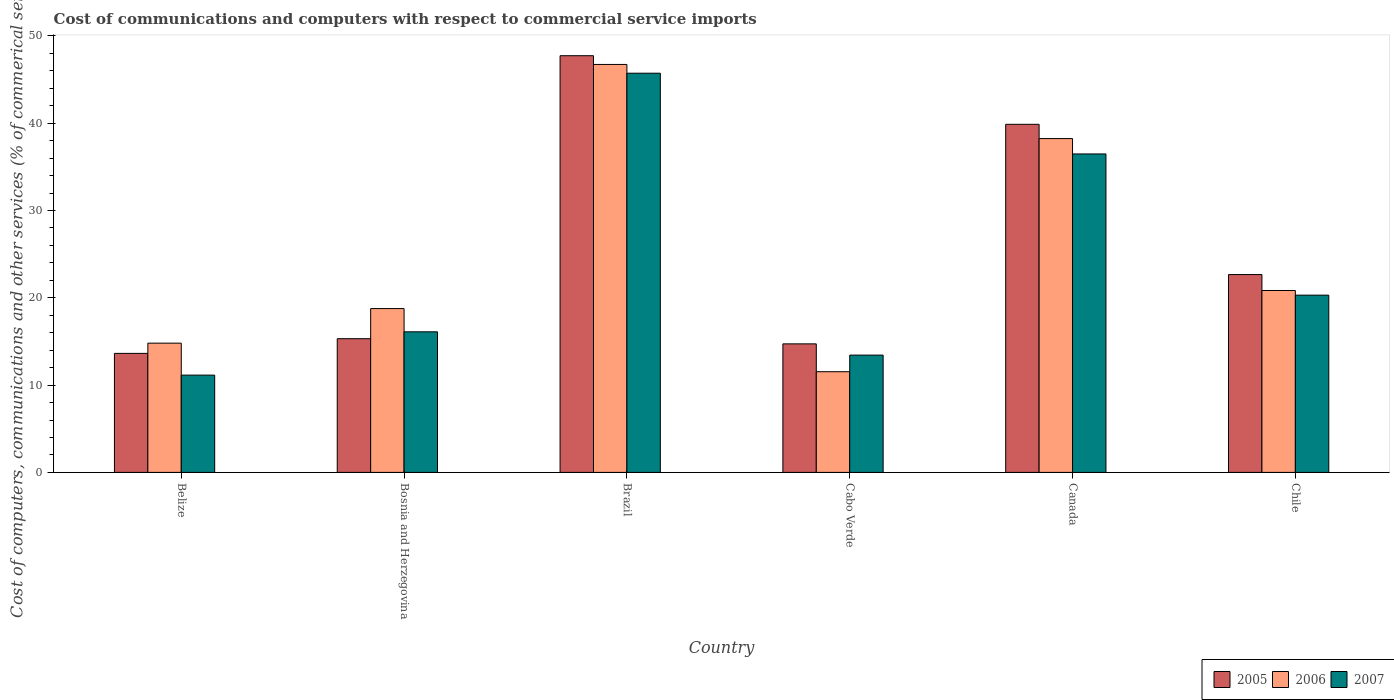How many different coloured bars are there?
Your response must be concise. 3. Are the number of bars per tick equal to the number of legend labels?
Provide a succinct answer. Yes. Are the number of bars on each tick of the X-axis equal?
Your response must be concise. Yes. How many bars are there on the 5th tick from the left?
Keep it short and to the point. 3. What is the label of the 1st group of bars from the left?
Give a very brief answer. Belize. What is the cost of communications and computers in 2005 in Chile?
Offer a very short reply. 22.66. Across all countries, what is the maximum cost of communications and computers in 2007?
Give a very brief answer. 45.72. Across all countries, what is the minimum cost of communications and computers in 2007?
Offer a very short reply. 11.14. In which country was the cost of communications and computers in 2006 maximum?
Provide a short and direct response. Brazil. In which country was the cost of communications and computers in 2005 minimum?
Make the answer very short. Belize. What is the total cost of communications and computers in 2005 in the graph?
Provide a short and direct response. 153.93. What is the difference between the cost of communications and computers in 2006 in Cabo Verde and that in Canada?
Provide a short and direct response. -26.7. What is the difference between the cost of communications and computers in 2006 in Chile and the cost of communications and computers in 2007 in Canada?
Your answer should be compact. -15.64. What is the average cost of communications and computers in 2005 per country?
Provide a succinct answer. 25.65. What is the difference between the cost of communications and computers of/in 2005 and cost of communications and computers of/in 2007 in Bosnia and Herzegovina?
Offer a terse response. -0.79. In how many countries, is the cost of communications and computers in 2005 greater than 44 %?
Ensure brevity in your answer.  1. What is the ratio of the cost of communications and computers in 2007 in Bosnia and Herzegovina to that in Brazil?
Keep it short and to the point. 0.35. What is the difference between the highest and the second highest cost of communications and computers in 2006?
Offer a terse response. 17.4. What is the difference between the highest and the lowest cost of communications and computers in 2006?
Your answer should be very brief. 35.19. Is the sum of the cost of communications and computers in 2007 in Cabo Verde and Canada greater than the maximum cost of communications and computers in 2005 across all countries?
Your answer should be very brief. Yes. Are all the bars in the graph horizontal?
Offer a very short reply. No. What is the difference between two consecutive major ticks on the Y-axis?
Your answer should be very brief. 10. Does the graph contain grids?
Offer a terse response. No. How many legend labels are there?
Make the answer very short. 3. How are the legend labels stacked?
Make the answer very short. Horizontal. What is the title of the graph?
Provide a succinct answer. Cost of communications and computers with respect to commercial service imports. What is the label or title of the Y-axis?
Give a very brief answer. Cost of computers, communications and other services (% of commerical service exports). What is the Cost of computers, communications and other services (% of commerical service exports) in 2005 in Belize?
Offer a very short reply. 13.63. What is the Cost of computers, communications and other services (% of commerical service exports) in 2006 in Belize?
Your response must be concise. 14.8. What is the Cost of computers, communications and other services (% of commerical service exports) of 2007 in Belize?
Make the answer very short. 11.14. What is the Cost of computers, communications and other services (% of commerical service exports) in 2005 in Bosnia and Herzegovina?
Your answer should be compact. 15.31. What is the Cost of computers, communications and other services (% of commerical service exports) in 2006 in Bosnia and Herzegovina?
Your response must be concise. 18.76. What is the Cost of computers, communications and other services (% of commerical service exports) in 2007 in Bosnia and Herzegovina?
Ensure brevity in your answer.  16.1. What is the Cost of computers, communications and other services (% of commerical service exports) in 2005 in Brazil?
Make the answer very short. 47.73. What is the Cost of computers, communications and other services (% of commerical service exports) in 2006 in Brazil?
Offer a very short reply. 46.73. What is the Cost of computers, communications and other services (% of commerical service exports) of 2007 in Brazil?
Offer a very short reply. 45.72. What is the Cost of computers, communications and other services (% of commerical service exports) of 2005 in Cabo Verde?
Provide a short and direct response. 14.72. What is the Cost of computers, communications and other services (% of commerical service exports) in 2006 in Cabo Verde?
Your response must be concise. 11.53. What is the Cost of computers, communications and other services (% of commerical service exports) in 2007 in Cabo Verde?
Provide a short and direct response. 13.44. What is the Cost of computers, communications and other services (% of commerical service exports) in 2005 in Canada?
Provide a succinct answer. 39.87. What is the Cost of computers, communications and other services (% of commerical service exports) in 2006 in Canada?
Your response must be concise. 38.24. What is the Cost of computers, communications and other services (% of commerical service exports) of 2007 in Canada?
Your answer should be very brief. 36.48. What is the Cost of computers, communications and other services (% of commerical service exports) of 2005 in Chile?
Your answer should be very brief. 22.66. What is the Cost of computers, communications and other services (% of commerical service exports) of 2006 in Chile?
Your answer should be very brief. 20.83. What is the Cost of computers, communications and other services (% of commerical service exports) in 2007 in Chile?
Keep it short and to the point. 20.3. Across all countries, what is the maximum Cost of computers, communications and other services (% of commerical service exports) of 2005?
Make the answer very short. 47.73. Across all countries, what is the maximum Cost of computers, communications and other services (% of commerical service exports) of 2006?
Your answer should be compact. 46.73. Across all countries, what is the maximum Cost of computers, communications and other services (% of commerical service exports) of 2007?
Give a very brief answer. 45.72. Across all countries, what is the minimum Cost of computers, communications and other services (% of commerical service exports) in 2005?
Offer a terse response. 13.63. Across all countries, what is the minimum Cost of computers, communications and other services (% of commerical service exports) of 2006?
Offer a terse response. 11.53. Across all countries, what is the minimum Cost of computers, communications and other services (% of commerical service exports) in 2007?
Provide a succinct answer. 11.14. What is the total Cost of computers, communications and other services (% of commerical service exports) in 2005 in the graph?
Offer a terse response. 153.93. What is the total Cost of computers, communications and other services (% of commerical service exports) of 2006 in the graph?
Offer a terse response. 150.9. What is the total Cost of computers, communications and other services (% of commerical service exports) in 2007 in the graph?
Offer a terse response. 143.18. What is the difference between the Cost of computers, communications and other services (% of commerical service exports) in 2005 in Belize and that in Bosnia and Herzegovina?
Make the answer very short. -1.68. What is the difference between the Cost of computers, communications and other services (% of commerical service exports) of 2006 in Belize and that in Bosnia and Herzegovina?
Provide a succinct answer. -3.96. What is the difference between the Cost of computers, communications and other services (% of commerical service exports) of 2007 in Belize and that in Bosnia and Herzegovina?
Your response must be concise. -4.96. What is the difference between the Cost of computers, communications and other services (% of commerical service exports) of 2005 in Belize and that in Brazil?
Ensure brevity in your answer.  -34.1. What is the difference between the Cost of computers, communications and other services (% of commerical service exports) of 2006 in Belize and that in Brazil?
Your answer should be compact. -31.92. What is the difference between the Cost of computers, communications and other services (% of commerical service exports) in 2007 in Belize and that in Brazil?
Your answer should be very brief. -34.58. What is the difference between the Cost of computers, communications and other services (% of commerical service exports) of 2005 in Belize and that in Cabo Verde?
Your response must be concise. -1.09. What is the difference between the Cost of computers, communications and other services (% of commerical service exports) in 2006 in Belize and that in Cabo Verde?
Offer a terse response. 3.27. What is the difference between the Cost of computers, communications and other services (% of commerical service exports) of 2007 in Belize and that in Cabo Verde?
Your response must be concise. -2.29. What is the difference between the Cost of computers, communications and other services (% of commerical service exports) of 2005 in Belize and that in Canada?
Make the answer very short. -26.24. What is the difference between the Cost of computers, communications and other services (% of commerical service exports) of 2006 in Belize and that in Canada?
Make the answer very short. -23.43. What is the difference between the Cost of computers, communications and other services (% of commerical service exports) in 2007 in Belize and that in Canada?
Provide a short and direct response. -25.33. What is the difference between the Cost of computers, communications and other services (% of commerical service exports) in 2005 in Belize and that in Chile?
Offer a very short reply. -9.03. What is the difference between the Cost of computers, communications and other services (% of commerical service exports) of 2006 in Belize and that in Chile?
Provide a succinct answer. -6.03. What is the difference between the Cost of computers, communications and other services (% of commerical service exports) of 2007 in Belize and that in Chile?
Keep it short and to the point. -9.16. What is the difference between the Cost of computers, communications and other services (% of commerical service exports) in 2005 in Bosnia and Herzegovina and that in Brazil?
Provide a succinct answer. -32.41. What is the difference between the Cost of computers, communications and other services (% of commerical service exports) in 2006 in Bosnia and Herzegovina and that in Brazil?
Your answer should be very brief. -27.96. What is the difference between the Cost of computers, communications and other services (% of commerical service exports) of 2007 in Bosnia and Herzegovina and that in Brazil?
Your answer should be compact. -29.62. What is the difference between the Cost of computers, communications and other services (% of commerical service exports) of 2005 in Bosnia and Herzegovina and that in Cabo Verde?
Offer a very short reply. 0.59. What is the difference between the Cost of computers, communications and other services (% of commerical service exports) in 2006 in Bosnia and Herzegovina and that in Cabo Verde?
Provide a short and direct response. 7.23. What is the difference between the Cost of computers, communications and other services (% of commerical service exports) of 2007 in Bosnia and Herzegovina and that in Cabo Verde?
Offer a very short reply. 2.67. What is the difference between the Cost of computers, communications and other services (% of commerical service exports) of 2005 in Bosnia and Herzegovina and that in Canada?
Offer a very short reply. -24.55. What is the difference between the Cost of computers, communications and other services (% of commerical service exports) in 2006 in Bosnia and Herzegovina and that in Canada?
Offer a terse response. -19.47. What is the difference between the Cost of computers, communications and other services (% of commerical service exports) of 2007 in Bosnia and Herzegovina and that in Canada?
Offer a terse response. -20.38. What is the difference between the Cost of computers, communications and other services (% of commerical service exports) of 2005 in Bosnia and Herzegovina and that in Chile?
Provide a short and direct response. -7.35. What is the difference between the Cost of computers, communications and other services (% of commerical service exports) in 2006 in Bosnia and Herzegovina and that in Chile?
Ensure brevity in your answer.  -2.07. What is the difference between the Cost of computers, communications and other services (% of commerical service exports) of 2007 in Bosnia and Herzegovina and that in Chile?
Ensure brevity in your answer.  -4.2. What is the difference between the Cost of computers, communications and other services (% of commerical service exports) in 2005 in Brazil and that in Cabo Verde?
Provide a short and direct response. 33.01. What is the difference between the Cost of computers, communications and other services (% of commerical service exports) of 2006 in Brazil and that in Cabo Verde?
Your answer should be very brief. 35.19. What is the difference between the Cost of computers, communications and other services (% of commerical service exports) in 2007 in Brazil and that in Cabo Verde?
Offer a very short reply. 32.29. What is the difference between the Cost of computers, communications and other services (% of commerical service exports) of 2005 in Brazil and that in Canada?
Ensure brevity in your answer.  7.86. What is the difference between the Cost of computers, communications and other services (% of commerical service exports) of 2006 in Brazil and that in Canada?
Your answer should be compact. 8.49. What is the difference between the Cost of computers, communications and other services (% of commerical service exports) in 2007 in Brazil and that in Canada?
Make the answer very short. 9.25. What is the difference between the Cost of computers, communications and other services (% of commerical service exports) of 2005 in Brazil and that in Chile?
Offer a terse response. 25.07. What is the difference between the Cost of computers, communications and other services (% of commerical service exports) in 2006 in Brazil and that in Chile?
Ensure brevity in your answer.  25.89. What is the difference between the Cost of computers, communications and other services (% of commerical service exports) of 2007 in Brazil and that in Chile?
Make the answer very short. 25.42. What is the difference between the Cost of computers, communications and other services (% of commerical service exports) in 2005 in Cabo Verde and that in Canada?
Provide a succinct answer. -25.15. What is the difference between the Cost of computers, communications and other services (% of commerical service exports) in 2006 in Cabo Verde and that in Canada?
Offer a very short reply. -26.7. What is the difference between the Cost of computers, communications and other services (% of commerical service exports) in 2007 in Cabo Verde and that in Canada?
Keep it short and to the point. -23.04. What is the difference between the Cost of computers, communications and other services (% of commerical service exports) in 2005 in Cabo Verde and that in Chile?
Offer a terse response. -7.94. What is the difference between the Cost of computers, communications and other services (% of commerical service exports) of 2007 in Cabo Verde and that in Chile?
Provide a short and direct response. -6.87. What is the difference between the Cost of computers, communications and other services (% of commerical service exports) of 2005 in Canada and that in Chile?
Offer a terse response. 17.21. What is the difference between the Cost of computers, communications and other services (% of commerical service exports) in 2006 in Canada and that in Chile?
Make the answer very short. 17.4. What is the difference between the Cost of computers, communications and other services (% of commerical service exports) of 2007 in Canada and that in Chile?
Offer a very short reply. 16.17. What is the difference between the Cost of computers, communications and other services (% of commerical service exports) in 2005 in Belize and the Cost of computers, communications and other services (% of commerical service exports) in 2006 in Bosnia and Herzegovina?
Your response must be concise. -5.13. What is the difference between the Cost of computers, communications and other services (% of commerical service exports) of 2005 in Belize and the Cost of computers, communications and other services (% of commerical service exports) of 2007 in Bosnia and Herzegovina?
Offer a terse response. -2.47. What is the difference between the Cost of computers, communications and other services (% of commerical service exports) in 2006 in Belize and the Cost of computers, communications and other services (% of commerical service exports) in 2007 in Bosnia and Herzegovina?
Your answer should be compact. -1.3. What is the difference between the Cost of computers, communications and other services (% of commerical service exports) in 2005 in Belize and the Cost of computers, communications and other services (% of commerical service exports) in 2006 in Brazil?
Give a very brief answer. -33.1. What is the difference between the Cost of computers, communications and other services (% of commerical service exports) of 2005 in Belize and the Cost of computers, communications and other services (% of commerical service exports) of 2007 in Brazil?
Ensure brevity in your answer.  -32.09. What is the difference between the Cost of computers, communications and other services (% of commerical service exports) in 2006 in Belize and the Cost of computers, communications and other services (% of commerical service exports) in 2007 in Brazil?
Give a very brief answer. -30.92. What is the difference between the Cost of computers, communications and other services (% of commerical service exports) of 2005 in Belize and the Cost of computers, communications and other services (% of commerical service exports) of 2006 in Cabo Verde?
Keep it short and to the point. 2.1. What is the difference between the Cost of computers, communications and other services (% of commerical service exports) in 2005 in Belize and the Cost of computers, communications and other services (% of commerical service exports) in 2007 in Cabo Verde?
Keep it short and to the point. 0.2. What is the difference between the Cost of computers, communications and other services (% of commerical service exports) of 2006 in Belize and the Cost of computers, communications and other services (% of commerical service exports) of 2007 in Cabo Verde?
Offer a very short reply. 1.37. What is the difference between the Cost of computers, communications and other services (% of commerical service exports) of 2005 in Belize and the Cost of computers, communications and other services (% of commerical service exports) of 2006 in Canada?
Your answer should be very brief. -24.6. What is the difference between the Cost of computers, communications and other services (% of commerical service exports) of 2005 in Belize and the Cost of computers, communications and other services (% of commerical service exports) of 2007 in Canada?
Keep it short and to the point. -22.84. What is the difference between the Cost of computers, communications and other services (% of commerical service exports) in 2006 in Belize and the Cost of computers, communications and other services (% of commerical service exports) in 2007 in Canada?
Your answer should be compact. -21.67. What is the difference between the Cost of computers, communications and other services (% of commerical service exports) in 2005 in Belize and the Cost of computers, communications and other services (% of commerical service exports) in 2006 in Chile?
Offer a terse response. -7.2. What is the difference between the Cost of computers, communications and other services (% of commerical service exports) of 2005 in Belize and the Cost of computers, communications and other services (% of commerical service exports) of 2007 in Chile?
Provide a succinct answer. -6.67. What is the difference between the Cost of computers, communications and other services (% of commerical service exports) of 2006 in Belize and the Cost of computers, communications and other services (% of commerical service exports) of 2007 in Chile?
Make the answer very short. -5.5. What is the difference between the Cost of computers, communications and other services (% of commerical service exports) in 2005 in Bosnia and Herzegovina and the Cost of computers, communications and other services (% of commerical service exports) in 2006 in Brazil?
Offer a very short reply. -31.41. What is the difference between the Cost of computers, communications and other services (% of commerical service exports) of 2005 in Bosnia and Herzegovina and the Cost of computers, communications and other services (% of commerical service exports) of 2007 in Brazil?
Provide a succinct answer. -30.41. What is the difference between the Cost of computers, communications and other services (% of commerical service exports) in 2006 in Bosnia and Herzegovina and the Cost of computers, communications and other services (% of commerical service exports) in 2007 in Brazil?
Ensure brevity in your answer.  -26.96. What is the difference between the Cost of computers, communications and other services (% of commerical service exports) of 2005 in Bosnia and Herzegovina and the Cost of computers, communications and other services (% of commerical service exports) of 2006 in Cabo Verde?
Provide a short and direct response. 3.78. What is the difference between the Cost of computers, communications and other services (% of commerical service exports) in 2005 in Bosnia and Herzegovina and the Cost of computers, communications and other services (% of commerical service exports) in 2007 in Cabo Verde?
Offer a terse response. 1.88. What is the difference between the Cost of computers, communications and other services (% of commerical service exports) in 2006 in Bosnia and Herzegovina and the Cost of computers, communications and other services (% of commerical service exports) in 2007 in Cabo Verde?
Provide a short and direct response. 5.33. What is the difference between the Cost of computers, communications and other services (% of commerical service exports) in 2005 in Bosnia and Herzegovina and the Cost of computers, communications and other services (% of commerical service exports) in 2006 in Canada?
Your answer should be compact. -22.92. What is the difference between the Cost of computers, communications and other services (% of commerical service exports) of 2005 in Bosnia and Herzegovina and the Cost of computers, communications and other services (% of commerical service exports) of 2007 in Canada?
Your response must be concise. -21.16. What is the difference between the Cost of computers, communications and other services (% of commerical service exports) of 2006 in Bosnia and Herzegovina and the Cost of computers, communications and other services (% of commerical service exports) of 2007 in Canada?
Your answer should be very brief. -17.71. What is the difference between the Cost of computers, communications and other services (% of commerical service exports) in 2005 in Bosnia and Herzegovina and the Cost of computers, communications and other services (% of commerical service exports) in 2006 in Chile?
Your answer should be very brief. -5.52. What is the difference between the Cost of computers, communications and other services (% of commerical service exports) in 2005 in Bosnia and Herzegovina and the Cost of computers, communications and other services (% of commerical service exports) in 2007 in Chile?
Your answer should be very brief. -4.99. What is the difference between the Cost of computers, communications and other services (% of commerical service exports) in 2006 in Bosnia and Herzegovina and the Cost of computers, communications and other services (% of commerical service exports) in 2007 in Chile?
Provide a short and direct response. -1.54. What is the difference between the Cost of computers, communications and other services (% of commerical service exports) in 2005 in Brazil and the Cost of computers, communications and other services (% of commerical service exports) in 2006 in Cabo Verde?
Keep it short and to the point. 36.2. What is the difference between the Cost of computers, communications and other services (% of commerical service exports) of 2005 in Brazil and the Cost of computers, communications and other services (% of commerical service exports) of 2007 in Cabo Verde?
Your response must be concise. 34.29. What is the difference between the Cost of computers, communications and other services (% of commerical service exports) in 2006 in Brazil and the Cost of computers, communications and other services (% of commerical service exports) in 2007 in Cabo Verde?
Ensure brevity in your answer.  33.29. What is the difference between the Cost of computers, communications and other services (% of commerical service exports) of 2005 in Brazil and the Cost of computers, communications and other services (% of commerical service exports) of 2006 in Canada?
Provide a short and direct response. 9.49. What is the difference between the Cost of computers, communications and other services (% of commerical service exports) in 2005 in Brazil and the Cost of computers, communications and other services (% of commerical service exports) in 2007 in Canada?
Make the answer very short. 11.25. What is the difference between the Cost of computers, communications and other services (% of commerical service exports) in 2006 in Brazil and the Cost of computers, communications and other services (% of commerical service exports) in 2007 in Canada?
Make the answer very short. 10.25. What is the difference between the Cost of computers, communications and other services (% of commerical service exports) of 2005 in Brazil and the Cost of computers, communications and other services (% of commerical service exports) of 2006 in Chile?
Ensure brevity in your answer.  26.89. What is the difference between the Cost of computers, communications and other services (% of commerical service exports) of 2005 in Brazil and the Cost of computers, communications and other services (% of commerical service exports) of 2007 in Chile?
Give a very brief answer. 27.43. What is the difference between the Cost of computers, communications and other services (% of commerical service exports) of 2006 in Brazil and the Cost of computers, communications and other services (% of commerical service exports) of 2007 in Chile?
Offer a very short reply. 26.42. What is the difference between the Cost of computers, communications and other services (% of commerical service exports) in 2005 in Cabo Verde and the Cost of computers, communications and other services (% of commerical service exports) in 2006 in Canada?
Your answer should be compact. -23.51. What is the difference between the Cost of computers, communications and other services (% of commerical service exports) of 2005 in Cabo Verde and the Cost of computers, communications and other services (% of commerical service exports) of 2007 in Canada?
Offer a very short reply. -21.75. What is the difference between the Cost of computers, communications and other services (% of commerical service exports) of 2006 in Cabo Verde and the Cost of computers, communications and other services (% of commerical service exports) of 2007 in Canada?
Give a very brief answer. -24.94. What is the difference between the Cost of computers, communications and other services (% of commerical service exports) of 2005 in Cabo Verde and the Cost of computers, communications and other services (% of commerical service exports) of 2006 in Chile?
Keep it short and to the point. -6.11. What is the difference between the Cost of computers, communications and other services (% of commerical service exports) in 2005 in Cabo Verde and the Cost of computers, communications and other services (% of commerical service exports) in 2007 in Chile?
Your answer should be compact. -5.58. What is the difference between the Cost of computers, communications and other services (% of commerical service exports) of 2006 in Cabo Verde and the Cost of computers, communications and other services (% of commerical service exports) of 2007 in Chile?
Ensure brevity in your answer.  -8.77. What is the difference between the Cost of computers, communications and other services (% of commerical service exports) of 2005 in Canada and the Cost of computers, communications and other services (% of commerical service exports) of 2006 in Chile?
Provide a short and direct response. 19.04. What is the difference between the Cost of computers, communications and other services (% of commerical service exports) in 2005 in Canada and the Cost of computers, communications and other services (% of commerical service exports) in 2007 in Chile?
Your answer should be very brief. 19.57. What is the difference between the Cost of computers, communications and other services (% of commerical service exports) in 2006 in Canada and the Cost of computers, communications and other services (% of commerical service exports) in 2007 in Chile?
Provide a short and direct response. 17.93. What is the average Cost of computers, communications and other services (% of commerical service exports) of 2005 per country?
Your answer should be compact. 25.65. What is the average Cost of computers, communications and other services (% of commerical service exports) of 2006 per country?
Provide a short and direct response. 25.15. What is the average Cost of computers, communications and other services (% of commerical service exports) in 2007 per country?
Keep it short and to the point. 23.86. What is the difference between the Cost of computers, communications and other services (% of commerical service exports) of 2005 and Cost of computers, communications and other services (% of commerical service exports) of 2006 in Belize?
Make the answer very short. -1.17. What is the difference between the Cost of computers, communications and other services (% of commerical service exports) of 2005 and Cost of computers, communications and other services (% of commerical service exports) of 2007 in Belize?
Your answer should be compact. 2.49. What is the difference between the Cost of computers, communications and other services (% of commerical service exports) in 2006 and Cost of computers, communications and other services (% of commerical service exports) in 2007 in Belize?
Offer a terse response. 3.66. What is the difference between the Cost of computers, communications and other services (% of commerical service exports) of 2005 and Cost of computers, communications and other services (% of commerical service exports) of 2006 in Bosnia and Herzegovina?
Your answer should be very brief. -3.45. What is the difference between the Cost of computers, communications and other services (% of commerical service exports) of 2005 and Cost of computers, communications and other services (% of commerical service exports) of 2007 in Bosnia and Herzegovina?
Provide a succinct answer. -0.79. What is the difference between the Cost of computers, communications and other services (% of commerical service exports) in 2006 and Cost of computers, communications and other services (% of commerical service exports) in 2007 in Bosnia and Herzegovina?
Your answer should be very brief. 2.66. What is the difference between the Cost of computers, communications and other services (% of commerical service exports) in 2005 and Cost of computers, communications and other services (% of commerical service exports) in 2007 in Brazil?
Offer a terse response. 2. What is the difference between the Cost of computers, communications and other services (% of commerical service exports) of 2006 and Cost of computers, communications and other services (% of commerical service exports) of 2007 in Brazil?
Give a very brief answer. 1. What is the difference between the Cost of computers, communications and other services (% of commerical service exports) in 2005 and Cost of computers, communications and other services (% of commerical service exports) in 2006 in Cabo Verde?
Provide a short and direct response. 3.19. What is the difference between the Cost of computers, communications and other services (% of commerical service exports) of 2005 and Cost of computers, communications and other services (% of commerical service exports) of 2007 in Cabo Verde?
Offer a terse response. 1.29. What is the difference between the Cost of computers, communications and other services (% of commerical service exports) in 2006 and Cost of computers, communications and other services (% of commerical service exports) in 2007 in Cabo Verde?
Your answer should be compact. -1.9. What is the difference between the Cost of computers, communications and other services (% of commerical service exports) in 2005 and Cost of computers, communications and other services (% of commerical service exports) in 2006 in Canada?
Offer a terse response. 1.63. What is the difference between the Cost of computers, communications and other services (% of commerical service exports) of 2005 and Cost of computers, communications and other services (% of commerical service exports) of 2007 in Canada?
Provide a succinct answer. 3.39. What is the difference between the Cost of computers, communications and other services (% of commerical service exports) of 2006 and Cost of computers, communications and other services (% of commerical service exports) of 2007 in Canada?
Your answer should be compact. 1.76. What is the difference between the Cost of computers, communications and other services (% of commerical service exports) in 2005 and Cost of computers, communications and other services (% of commerical service exports) in 2006 in Chile?
Ensure brevity in your answer.  1.83. What is the difference between the Cost of computers, communications and other services (% of commerical service exports) in 2005 and Cost of computers, communications and other services (% of commerical service exports) in 2007 in Chile?
Keep it short and to the point. 2.36. What is the difference between the Cost of computers, communications and other services (% of commerical service exports) in 2006 and Cost of computers, communications and other services (% of commerical service exports) in 2007 in Chile?
Offer a very short reply. 0.53. What is the ratio of the Cost of computers, communications and other services (% of commerical service exports) in 2005 in Belize to that in Bosnia and Herzegovina?
Provide a succinct answer. 0.89. What is the ratio of the Cost of computers, communications and other services (% of commerical service exports) in 2006 in Belize to that in Bosnia and Herzegovina?
Provide a short and direct response. 0.79. What is the ratio of the Cost of computers, communications and other services (% of commerical service exports) of 2007 in Belize to that in Bosnia and Herzegovina?
Your answer should be very brief. 0.69. What is the ratio of the Cost of computers, communications and other services (% of commerical service exports) of 2005 in Belize to that in Brazil?
Offer a very short reply. 0.29. What is the ratio of the Cost of computers, communications and other services (% of commerical service exports) of 2006 in Belize to that in Brazil?
Provide a short and direct response. 0.32. What is the ratio of the Cost of computers, communications and other services (% of commerical service exports) in 2007 in Belize to that in Brazil?
Your answer should be very brief. 0.24. What is the ratio of the Cost of computers, communications and other services (% of commerical service exports) of 2005 in Belize to that in Cabo Verde?
Make the answer very short. 0.93. What is the ratio of the Cost of computers, communications and other services (% of commerical service exports) of 2006 in Belize to that in Cabo Verde?
Provide a succinct answer. 1.28. What is the ratio of the Cost of computers, communications and other services (% of commerical service exports) in 2007 in Belize to that in Cabo Verde?
Provide a short and direct response. 0.83. What is the ratio of the Cost of computers, communications and other services (% of commerical service exports) of 2005 in Belize to that in Canada?
Ensure brevity in your answer.  0.34. What is the ratio of the Cost of computers, communications and other services (% of commerical service exports) in 2006 in Belize to that in Canada?
Your response must be concise. 0.39. What is the ratio of the Cost of computers, communications and other services (% of commerical service exports) in 2007 in Belize to that in Canada?
Keep it short and to the point. 0.31. What is the ratio of the Cost of computers, communications and other services (% of commerical service exports) in 2005 in Belize to that in Chile?
Offer a terse response. 0.6. What is the ratio of the Cost of computers, communications and other services (% of commerical service exports) in 2006 in Belize to that in Chile?
Keep it short and to the point. 0.71. What is the ratio of the Cost of computers, communications and other services (% of commerical service exports) in 2007 in Belize to that in Chile?
Give a very brief answer. 0.55. What is the ratio of the Cost of computers, communications and other services (% of commerical service exports) of 2005 in Bosnia and Herzegovina to that in Brazil?
Offer a very short reply. 0.32. What is the ratio of the Cost of computers, communications and other services (% of commerical service exports) in 2006 in Bosnia and Herzegovina to that in Brazil?
Offer a terse response. 0.4. What is the ratio of the Cost of computers, communications and other services (% of commerical service exports) of 2007 in Bosnia and Herzegovina to that in Brazil?
Your answer should be very brief. 0.35. What is the ratio of the Cost of computers, communications and other services (% of commerical service exports) of 2005 in Bosnia and Herzegovina to that in Cabo Verde?
Ensure brevity in your answer.  1.04. What is the ratio of the Cost of computers, communications and other services (% of commerical service exports) in 2006 in Bosnia and Herzegovina to that in Cabo Verde?
Give a very brief answer. 1.63. What is the ratio of the Cost of computers, communications and other services (% of commerical service exports) in 2007 in Bosnia and Herzegovina to that in Cabo Verde?
Give a very brief answer. 1.2. What is the ratio of the Cost of computers, communications and other services (% of commerical service exports) of 2005 in Bosnia and Herzegovina to that in Canada?
Ensure brevity in your answer.  0.38. What is the ratio of the Cost of computers, communications and other services (% of commerical service exports) of 2006 in Bosnia and Herzegovina to that in Canada?
Give a very brief answer. 0.49. What is the ratio of the Cost of computers, communications and other services (% of commerical service exports) of 2007 in Bosnia and Herzegovina to that in Canada?
Provide a succinct answer. 0.44. What is the ratio of the Cost of computers, communications and other services (% of commerical service exports) of 2005 in Bosnia and Herzegovina to that in Chile?
Provide a short and direct response. 0.68. What is the ratio of the Cost of computers, communications and other services (% of commerical service exports) in 2006 in Bosnia and Herzegovina to that in Chile?
Keep it short and to the point. 0.9. What is the ratio of the Cost of computers, communications and other services (% of commerical service exports) in 2007 in Bosnia and Herzegovina to that in Chile?
Give a very brief answer. 0.79. What is the ratio of the Cost of computers, communications and other services (% of commerical service exports) of 2005 in Brazil to that in Cabo Verde?
Your answer should be very brief. 3.24. What is the ratio of the Cost of computers, communications and other services (% of commerical service exports) in 2006 in Brazil to that in Cabo Verde?
Your answer should be compact. 4.05. What is the ratio of the Cost of computers, communications and other services (% of commerical service exports) in 2007 in Brazil to that in Cabo Verde?
Make the answer very short. 3.4. What is the ratio of the Cost of computers, communications and other services (% of commerical service exports) of 2005 in Brazil to that in Canada?
Provide a short and direct response. 1.2. What is the ratio of the Cost of computers, communications and other services (% of commerical service exports) in 2006 in Brazil to that in Canada?
Provide a short and direct response. 1.22. What is the ratio of the Cost of computers, communications and other services (% of commerical service exports) in 2007 in Brazil to that in Canada?
Keep it short and to the point. 1.25. What is the ratio of the Cost of computers, communications and other services (% of commerical service exports) in 2005 in Brazil to that in Chile?
Your response must be concise. 2.11. What is the ratio of the Cost of computers, communications and other services (% of commerical service exports) in 2006 in Brazil to that in Chile?
Keep it short and to the point. 2.24. What is the ratio of the Cost of computers, communications and other services (% of commerical service exports) in 2007 in Brazil to that in Chile?
Your answer should be very brief. 2.25. What is the ratio of the Cost of computers, communications and other services (% of commerical service exports) in 2005 in Cabo Verde to that in Canada?
Ensure brevity in your answer.  0.37. What is the ratio of the Cost of computers, communications and other services (% of commerical service exports) in 2006 in Cabo Verde to that in Canada?
Provide a short and direct response. 0.3. What is the ratio of the Cost of computers, communications and other services (% of commerical service exports) of 2007 in Cabo Verde to that in Canada?
Give a very brief answer. 0.37. What is the ratio of the Cost of computers, communications and other services (% of commerical service exports) in 2005 in Cabo Verde to that in Chile?
Keep it short and to the point. 0.65. What is the ratio of the Cost of computers, communications and other services (% of commerical service exports) of 2006 in Cabo Verde to that in Chile?
Offer a terse response. 0.55. What is the ratio of the Cost of computers, communications and other services (% of commerical service exports) in 2007 in Cabo Verde to that in Chile?
Keep it short and to the point. 0.66. What is the ratio of the Cost of computers, communications and other services (% of commerical service exports) in 2005 in Canada to that in Chile?
Offer a very short reply. 1.76. What is the ratio of the Cost of computers, communications and other services (% of commerical service exports) of 2006 in Canada to that in Chile?
Your response must be concise. 1.84. What is the ratio of the Cost of computers, communications and other services (% of commerical service exports) of 2007 in Canada to that in Chile?
Your response must be concise. 1.8. What is the difference between the highest and the second highest Cost of computers, communications and other services (% of commerical service exports) of 2005?
Provide a short and direct response. 7.86. What is the difference between the highest and the second highest Cost of computers, communications and other services (% of commerical service exports) in 2006?
Provide a short and direct response. 8.49. What is the difference between the highest and the second highest Cost of computers, communications and other services (% of commerical service exports) in 2007?
Ensure brevity in your answer.  9.25. What is the difference between the highest and the lowest Cost of computers, communications and other services (% of commerical service exports) in 2005?
Provide a succinct answer. 34.1. What is the difference between the highest and the lowest Cost of computers, communications and other services (% of commerical service exports) of 2006?
Ensure brevity in your answer.  35.19. What is the difference between the highest and the lowest Cost of computers, communications and other services (% of commerical service exports) of 2007?
Offer a very short reply. 34.58. 